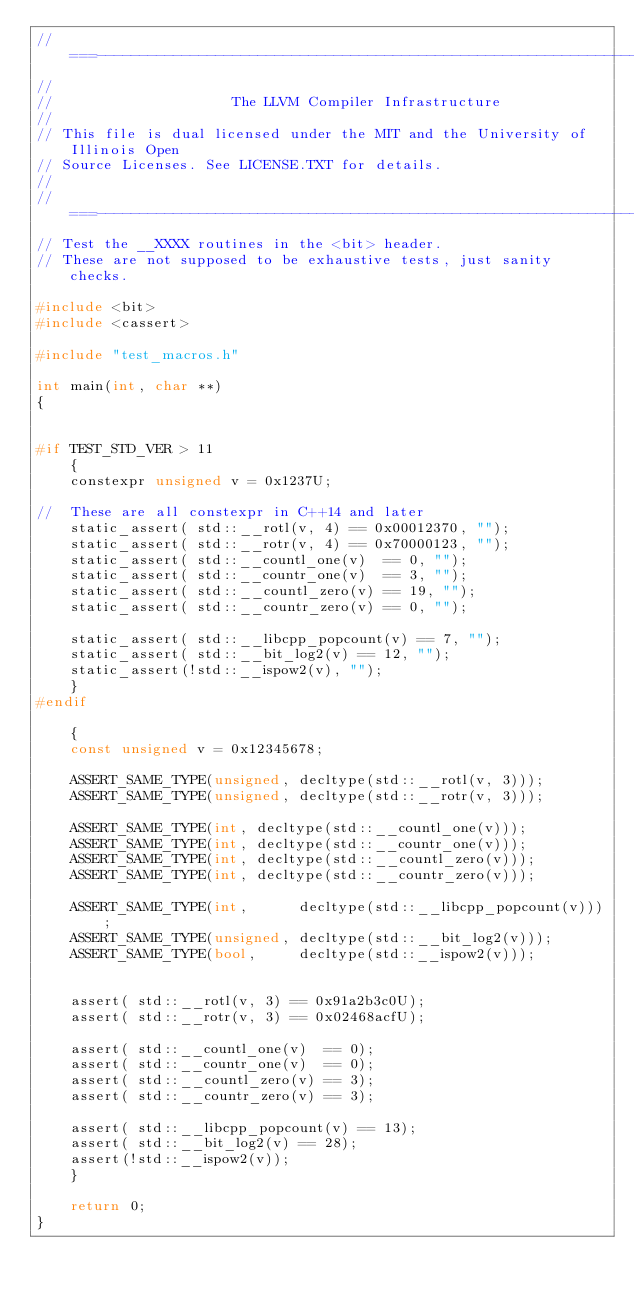<code> <loc_0><loc_0><loc_500><loc_500><_C++_>//===----------------------------------------------------------------------===//
//
//                     The LLVM Compiler Infrastructure
//
// This file is dual licensed under the MIT and the University of Illinois Open
// Source Licenses. See LICENSE.TXT for details.
//
//===----------------------------------------------------------------------===//
// Test the __XXXX routines in the <bit> header.
// These are not supposed to be exhaustive tests, just sanity checks.

#include <bit>
#include <cassert>

#include "test_macros.h"

int main(int, char **)
{


#if TEST_STD_VER > 11
    {
    constexpr unsigned v = 0x1237U;

//  These are all constexpr in C++14 and later
    static_assert( std::__rotl(v, 4) == 0x00012370, "");
    static_assert( std::__rotr(v, 4) == 0x70000123, "");
    static_assert( std::__countl_one(v)  == 0, "");
    static_assert( std::__countr_one(v)  == 3, "");
    static_assert( std::__countl_zero(v) == 19, "");
    static_assert( std::__countr_zero(v) == 0, "");

    static_assert( std::__libcpp_popcount(v) == 7, "");
    static_assert( std::__bit_log2(v) == 12, "");
    static_assert(!std::__ispow2(v), "");
    }
#endif

    {
    const unsigned v = 0x12345678;

    ASSERT_SAME_TYPE(unsigned, decltype(std::__rotl(v, 3)));
    ASSERT_SAME_TYPE(unsigned, decltype(std::__rotr(v, 3)));

    ASSERT_SAME_TYPE(int, decltype(std::__countl_one(v)));
    ASSERT_SAME_TYPE(int, decltype(std::__countr_one(v)));
    ASSERT_SAME_TYPE(int, decltype(std::__countl_zero(v)));
    ASSERT_SAME_TYPE(int, decltype(std::__countr_zero(v)));

    ASSERT_SAME_TYPE(int,      decltype(std::__libcpp_popcount(v)));
    ASSERT_SAME_TYPE(unsigned, decltype(std::__bit_log2(v)));
    ASSERT_SAME_TYPE(bool,     decltype(std::__ispow2(v)));


    assert( std::__rotl(v, 3) == 0x91a2b3c0U);
    assert( std::__rotr(v, 3) == 0x02468acfU);

    assert( std::__countl_one(v)  == 0);
    assert( std::__countr_one(v)  == 0);
    assert( std::__countl_zero(v) == 3);
    assert( std::__countr_zero(v) == 3);

    assert( std::__libcpp_popcount(v) == 13);
    assert( std::__bit_log2(v) == 28);
    assert(!std::__ispow2(v));
    }

    return 0;
}
</code> 